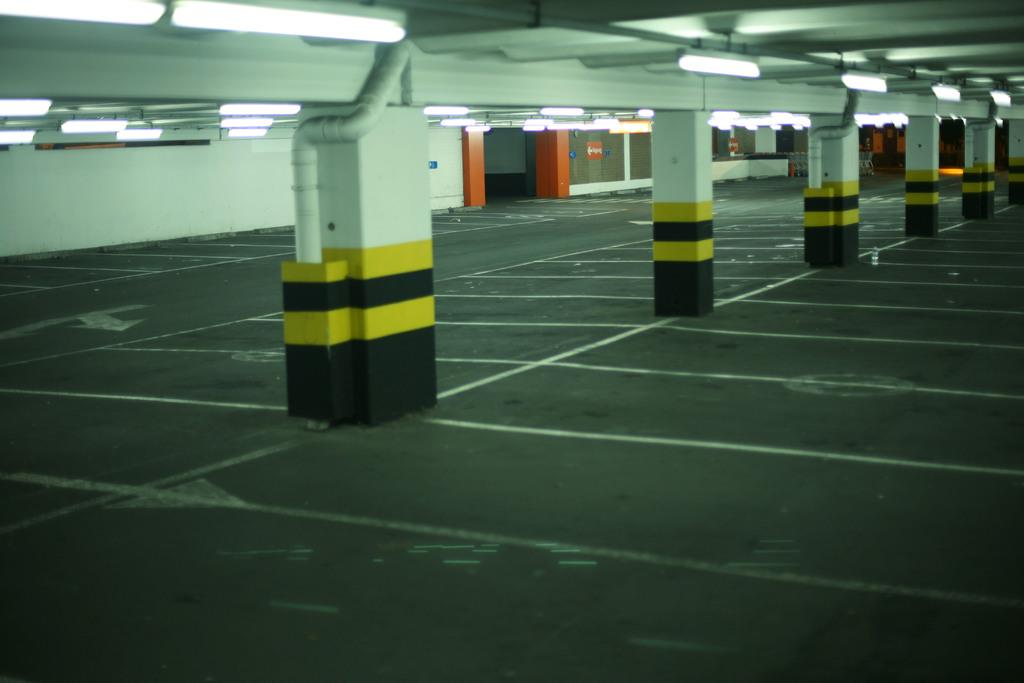What structures are located in the center of the image? There are pillars in the center of the image. What other objects can be seen in the image? There are pipes visible in the image. What is in the background of the image? There is a wall in the background of the image. What is located at the top of the image? There are lights on the top of the image. Can you see a person walking a dog in the image? There is no person or dog present in the image. Is there a baseball game happening in the image? There is no baseball game or any reference to sports in the image. 